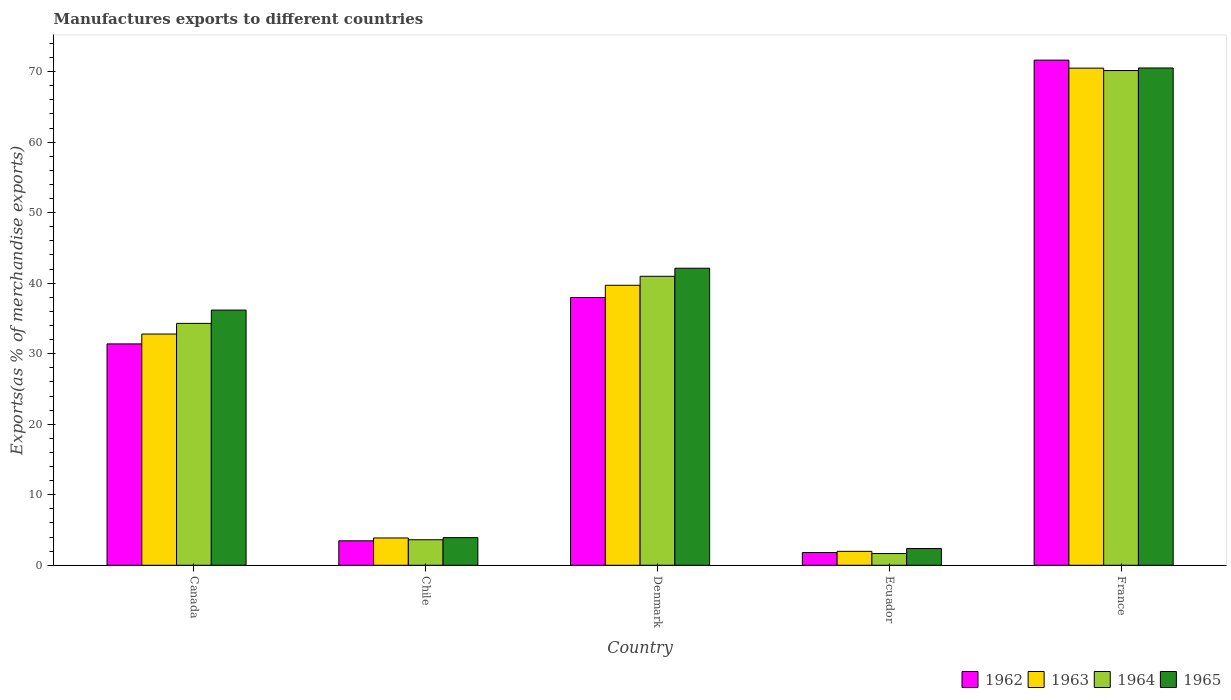How many different coloured bars are there?
Make the answer very short. 4. Are the number of bars per tick equal to the number of legend labels?
Make the answer very short. Yes. Are the number of bars on each tick of the X-axis equal?
Ensure brevity in your answer.  Yes. What is the label of the 4th group of bars from the left?
Ensure brevity in your answer.  Ecuador. What is the percentage of exports to different countries in 1965 in Ecuador?
Offer a very short reply. 2.37. Across all countries, what is the maximum percentage of exports to different countries in 1962?
Make the answer very short. 71.64. Across all countries, what is the minimum percentage of exports to different countries in 1962?
Keep it short and to the point. 1.8. In which country was the percentage of exports to different countries in 1965 maximum?
Give a very brief answer. France. In which country was the percentage of exports to different countries in 1962 minimum?
Your answer should be very brief. Ecuador. What is the total percentage of exports to different countries in 1964 in the graph?
Offer a terse response. 150.72. What is the difference between the percentage of exports to different countries in 1963 in Denmark and that in Ecuador?
Your response must be concise. 37.73. What is the difference between the percentage of exports to different countries in 1965 in Canada and the percentage of exports to different countries in 1964 in Denmark?
Your answer should be very brief. -4.79. What is the average percentage of exports to different countries in 1965 per country?
Give a very brief answer. 31.03. What is the difference between the percentage of exports to different countries of/in 1964 and percentage of exports to different countries of/in 1965 in France?
Your answer should be very brief. -0.36. In how many countries, is the percentage of exports to different countries in 1964 greater than 68 %?
Offer a terse response. 1. What is the ratio of the percentage of exports to different countries in 1965 in Denmark to that in Ecuador?
Offer a very short reply. 17.75. What is the difference between the highest and the second highest percentage of exports to different countries in 1963?
Give a very brief answer. -37.71. What is the difference between the highest and the lowest percentage of exports to different countries in 1963?
Provide a succinct answer. 68.53. Is it the case that in every country, the sum of the percentage of exports to different countries in 1965 and percentage of exports to different countries in 1962 is greater than the percentage of exports to different countries in 1963?
Provide a succinct answer. Yes. What is the difference between two consecutive major ticks on the Y-axis?
Keep it short and to the point. 10. Are the values on the major ticks of Y-axis written in scientific E-notation?
Your answer should be compact. No. Does the graph contain any zero values?
Make the answer very short. No. Does the graph contain grids?
Offer a very short reply. No. How many legend labels are there?
Offer a very short reply. 4. How are the legend labels stacked?
Your answer should be very brief. Horizontal. What is the title of the graph?
Your answer should be very brief. Manufactures exports to different countries. What is the label or title of the X-axis?
Offer a very short reply. Country. What is the label or title of the Y-axis?
Offer a very short reply. Exports(as % of merchandise exports). What is the Exports(as % of merchandise exports) of 1962 in Canada?
Give a very brief answer. 31.39. What is the Exports(as % of merchandise exports) in 1963 in Canada?
Your answer should be very brief. 32.79. What is the Exports(as % of merchandise exports) of 1964 in Canada?
Offer a very short reply. 34.3. What is the Exports(as % of merchandise exports) of 1965 in Canada?
Ensure brevity in your answer.  36.19. What is the Exports(as % of merchandise exports) in 1962 in Chile?
Your answer should be compact. 3.47. What is the Exports(as % of merchandise exports) of 1963 in Chile?
Offer a terse response. 3.87. What is the Exports(as % of merchandise exports) of 1964 in Chile?
Your answer should be compact. 3.62. What is the Exports(as % of merchandise exports) in 1965 in Chile?
Your answer should be compact. 3.92. What is the Exports(as % of merchandise exports) in 1962 in Denmark?
Your answer should be compact. 37.97. What is the Exports(as % of merchandise exports) in 1963 in Denmark?
Offer a very short reply. 39.71. What is the Exports(as % of merchandise exports) in 1964 in Denmark?
Your response must be concise. 40.98. What is the Exports(as % of merchandise exports) of 1965 in Denmark?
Offer a terse response. 42.12. What is the Exports(as % of merchandise exports) of 1962 in Ecuador?
Your response must be concise. 1.8. What is the Exports(as % of merchandise exports) in 1963 in Ecuador?
Provide a short and direct response. 1.97. What is the Exports(as % of merchandise exports) of 1964 in Ecuador?
Your response must be concise. 1.66. What is the Exports(as % of merchandise exports) in 1965 in Ecuador?
Provide a short and direct response. 2.37. What is the Exports(as % of merchandise exports) of 1962 in France?
Your answer should be compact. 71.64. What is the Exports(as % of merchandise exports) of 1963 in France?
Provide a short and direct response. 70.5. What is the Exports(as % of merchandise exports) in 1964 in France?
Give a very brief answer. 70.16. What is the Exports(as % of merchandise exports) of 1965 in France?
Your response must be concise. 70.52. Across all countries, what is the maximum Exports(as % of merchandise exports) in 1962?
Keep it short and to the point. 71.64. Across all countries, what is the maximum Exports(as % of merchandise exports) in 1963?
Offer a very short reply. 70.5. Across all countries, what is the maximum Exports(as % of merchandise exports) of 1964?
Offer a very short reply. 70.16. Across all countries, what is the maximum Exports(as % of merchandise exports) in 1965?
Offer a very short reply. 70.52. Across all countries, what is the minimum Exports(as % of merchandise exports) in 1962?
Provide a succinct answer. 1.8. Across all countries, what is the minimum Exports(as % of merchandise exports) of 1963?
Offer a terse response. 1.97. Across all countries, what is the minimum Exports(as % of merchandise exports) in 1964?
Your answer should be compact. 1.66. Across all countries, what is the minimum Exports(as % of merchandise exports) in 1965?
Offer a terse response. 2.37. What is the total Exports(as % of merchandise exports) of 1962 in the graph?
Provide a short and direct response. 146.27. What is the total Exports(as % of merchandise exports) in 1963 in the graph?
Provide a succinct answer. 148.84. What is the total Exports(as % of merchandise exports) of 1964 in the graph?
Offer a terse response. 150.72. What is the total Exports(as % of merchandise exports) in 1965 in the graph?
Make the answer very short. 155.13. What is the difference between the Exports(as % of merchandise exports) in 1962 in Canada and that in Chile?
Make the answer very short. 27.92. What is the difference between the Exports(as % of merchandise exports) of 1963 in Canada and that in Chile?
Provide a succinct answer. 28.92. What is the difference between the Exports(as % of merchandise exports) of 1964 in Canada and that in Chile?
Make the answer very short. 30.69. What is the difference between the Exports(as % of merchandise exports) of 1965 in Canada and that in Chile?
Offer a very short reply. 32.27. What is the difference between the Exports(as % of merchandise exports) in 1962 in Canada and that in Denmark?
Provide a succinct answer. -6.58. What is the difference between the Exports(as % of merchandise exports) in 1963 in Canada and that in Denmark?
Your answer should be compact. -6.92. What is the difference between the Exports(as % of merchandise exports) of 1964 in Canada and that in Denmark?
Your answer should be very brief. -6.68. What is the difference between the Exports(as % of merchandise exports) of 1965 in Canada and that in Denmark?
Give a very brief answer. -5.94. What is the difference between the Exports(as % of merchandise exports) of 1962 in Canada and that in Ecuador?
Offer a very short reply. 29.59. What is the difference between the Exports(as % of merchandise exports) in 1963 in Canada and that in Ecuador?
Give a very brief answer. 30.82. What is the difference between the Exports(as % of merchandise exports) in 1964 in Canada and that in Ecuador?
Your response must be concise. 32.64. What is the difference between the Exports(as % of merchandise exports) in 1965 in Canada and that in Ecuador?
Provide a short and direct response. 33.81. What is the difference between the Exports(as % of merchandise exports) of 1962 in Canada and that in France?
Provide a short and direct response. -40.24. What is the difference between the Exports(as % of merchandise exports) in 1963 in Canada and that in France?
Your answer should be very brief. -37.71. What is the difference between the Exports(as % of merchandise exports) in 1964 in Canada and that in France?
Give a very brief answer. -35.86. What is the difference between the Exports(as % of merchandise exports) of 1965 in Canada and that in France?
Give a very brief answer. -34.33. What is the difference between the Exports(as % of merchandise exports) of 1962 in Chile and that in Denmark?
Provide a short and direct response. -34.5. What is the difference between the Exports(as % of merchandise exports) of 1963 in Chile and that in Denmark?
Your answer should be compact. -35.84. What is the difference between the Exports(as % of merchandise exports) of 1964 in Chile and that in Denmark?
Provide a short and direct response. -37.36. What is the difference between the Exports(as % of merchandise exports) of 1965 in Chile and that in Denmark?
Your answer should be very brief. -38.21. What is the difference between the Exports(as % of merchandise exports) of 1962 in Chile and that in Ecuador?
Make the answer very short. 1.67. What is the difference between the Exports(as % of merchandise exports) in 1963 in Chile and that in Ecuador?
Ensure brevity in your answer.  1.9. What is the difference between the Exports(as % of merchandise exports) of 1964 in Chile and that in Ecuador?
Your answer should be very brief. 1.95. What is the difference between the Exports(as % of merchandise exports) of 1965 in Chile and that in Ecuador?
Ensure brevity in your answer.  1.54. What is the difference between the Exports(as % of merchandise exports) in 1962 in Chile and that in France?
Provide a succinct answer. -68.17. What is the difference between the Exports(as % of merchandise exports) of 1963 in Chile and that in France?
Make the answer very short. -66.63. What is the difference between the Exports(as % of merchandise exports) of 1964 in Chile and that in France?
Keep it short and to the point. -66.54. What is the difference between the Exports(as % of merchandise exports) in 1965 in Chile and that in France?
Your answer should be compact. -66.6. What is the difference between the Exports(as % of merchandise exports) in 1962 in Denmark and that in Ecuador?
Keep it short and to the point. 36.17. What is the difference between the Exports(as % of merchandise exports) of 1963 in Denmark and that in Ecuador?
Ensure brevity in your answer.  37.73. What is the difference between the Exports(as % of merchandise exports) of 1964 in Denmark and that in Ecuador?
Your answer should be very brief. 39.32. What is the difference between the Exports(as % of merchandise exports) of 1965 in Denmark and that in Ecuador?
Keep it short and to the point. 39.75. What is the difference between the Exports(as % of merchandise exports) of 1962 in Denmark and that in France?
Your answer should be very brief. -33.66. What is the difference between the Exports(as % of merchandise exports) in 1963 in Denmark and that in France?
Your answer should be compact. -30.79. What is the difference between the Exports(as % of merchandise exports) in 1964 in Denmark and that in France?
Give a very brief answer. -29.18. What is the difference between the Exports(as % of merchandise exports) in 1965 in Denmark and that in France?
Give a very brief answer. -28.4. What is the difference between the Exports(as % of merchandise exports) in 1962 in Ecuador and that in France?
Give a very brief answer. -69.83. What is the difference between the Exports(as % of merchandise exports) in 1963 in Ecuador and that in France?
Give a very brief answer. -68.53. What is the difference between the Exports(as % of merchandise exports) in 1964 in Ecuador and that in France?
Your response must be concise. -68.5. What is the difference between the Exports(as % of merchandise exports) in 1965 in Ecuador and that in France?
Provide a short and direct response. -68.15. What is the difference between the Exports(as % of merchandise exports) of 1962 in Canada and the Exports(as % of merchandise exports) of 1963 in Chile?
Give a very brief answer. 27.52. What is the difference between the Exports(as % of merchandise exports) of 1962 in Canada and the Exports(as % of merchandise exports) of 1964 in Chile?
Offer a terse response. 27.77. What is the difference between the Exports(as % of merchandise exports) of 1962 in Canada and the Exports(as % of merchandise exports) of 1965 in Chile?
Your answer should be compact. 27.47. What is the difference between the Exports(as % of merchandise exports) in 1963 in Canada and the Exports(as % of merchandise exports) in 1964 in Chile?
Provide a short and direct response. 29.17. What is the difference between the Exports(as % of merchandise exports) in 1963 in Canada and the Exports(as % of merchandise exports) in 1965 in Chile?
Your answer should be very brief. 28.87. What is the difference between the Exports(as % of merchandise exports) in 1964 in Canada and the Exports(as % of merchandise exports) in 1965 in Chile?
Your answer should be very brief. 30.39. What is the difference between the Exports(as % of merchandise exports) of 1962 in Canada and the Exports(as % of merchandise exports) of 1963 in Denmark?
Ensure brevity in your answer.  -8.31. What is the difference between the Exports(as % of merchandise exports) of 1962 in Canada and the Exports(as % of merchandise exports) of 1964 in Denmark?
Give a very brief answer. -9.59. What is the difference between the Exports(as % of merchandise exports) in 1962 in Canada and the Exports(as % of merchandise exports) in 1965 in Denmark?
Provide a succinct answer. -10.73. What is the difference between the Exports(as % of merchandise exports) of 1963 in Canada and the Exports(as % of merchandise exports) of 1964 in Denmark?
Keep it short and to the point. -8.19. What is the difference between the Exports(as % of merchandise exports) in 1963 in Canada and the Exports(as % of merchandise exports) in 1965 in Denmark?
Your answer should be compact. -9.33. What is the difference between the Exports(as % of merchandise exports) in 1964 in Canada and the Exports(as % of merchandise exports) in 1965 in Denmark?
Provide a succinct answer. -7.82. What is the difference between the Exports(as % of merchandise exports) in 1962 in Canada and the Exports(as % of merchandise exports) in 1963 in Ecuador?
Make the answer very short. 29.42. What is the difference between the Exports(as % of merchandise exports) in 1962 in Canada and the Exports(as % of merchandise exports) in 1964 in Ecuador?
Ensure brevity in your answer.  29.73. What is the difference between the Exports(as % of merchandise exports) in 1962 in Canada and the Exports(as % of merchandise exports) in 1965 in Ecuador?
Provide a succinct answer. 29.02. What is the difference between the Exports(as % of merchandise exports) of 1963 in Canada and the Exports(as % of merchandise exports) of 1964 in Ecuador?
Give a very brief answer. 31.13. What is the difference between the Exports(as % of merchandise exports) of 1963 in Canada and the Exports(as % of merchandise exports) of 1965 in Ecuador?
Your answer should be very brief. 30.42. What is the difference between the Exports(as % of merchandise exports) in 1964 in Canada and the Exports(as % of merchandise exports) in 1965 in Ecuador?
Your response must be concise. 31.93. What is the difference between the Exports(as % of merchandise exports) of 1962 in Canada and the Exports(as % of merchandise exports) of 1963 in France?
Offer a very short reply. -39.11. What is the difference between the Exports(as % of merchandise exports) in 1962 in Canada and the Exports(as % of merchandise exports) in 1964 in France?
Your response must be concise. -38.77. What is the difference between the Exports(as % of merchandise exports) in 1962 in Canada and the Exports(as % of merchandise exports) in 1965 in France?
Provide a succinct answer. -39.13. What is the difference between the Exports(as % of merchandise exports) in 1963 in Canada and the Exports(as % of merchandise exports) in 1964 in France?
Ensure brevity in your answer.  -37.37. What is the difference between the Exports(as % of merchandise exports) in 1963 in Canada and the Exports(as % of merchandise exports) in 1965 in France?
Offer a terse response. -37.73. What is the difference between the Exports(as % of merchandise exports) in 1964 in Canada and the Exports(as % of merchandise exports) in 1965 in France?
Give a very brief answer. -36.22. What is the difference between the Exports(as % of merchandise exports) in 1962 in Chile and the Exports(as % of merchandise exports) in 1963 in Denmark?
Your answer should be compact. -36.24. What is the difference between the Exports(as % of merchandise exports) of 1962 in Chile and the Exports(as % of merchandise exports) of 1964 in Denmark?
Make the answer very short. -37.51. What is the difference between the Exports(as % of merchandise exports) in 1962 in Chile and the Exports(as % of merchandise exports) in 1965 in Denmark?
Ensure brevity in your answer.  -38.66. What is the difference between the Exports(as % of merchandise exports) of 1963 in Chile and the Exports(as % of merchandise exports) of 1964 in Denmark?
Ensure brevity in your answer.  -37.11. What is the difference between the Exports(as % of merchandise exports) in 1963 in Chile and the Exports(as % of merchandise exports) in 1965 in Denmark?
Offer a terse response. -38.25. What is the difference between the Exports(as % of merchandise exports) in 1964 in Chile and the Exports(as % of merchandise exports) in 1965 in Denmark?
Provide a succinct answer. -38.51. What is the difference between the Exports(as % of merchandise exports) of 1962 in Chile and the Exports(as % of merchandise exports) of 1963 in Ecuador?
Keep it short and to the point. 1.49. What is the difference between the Exports(as % of merchandise exports) of 1962 in Chile and the Exports(as % of merchandise exports) of 1964 in Ecuador?
Your answer should be compact. 1.81. What is the difference between the Exports(as % of merchandise exports) in 1962 in Chile and the Exports(as % of merchandise exports) in 1965 in Ecuador?
Offer a very short reply. 1.1. What is the difference between the Exports(as % of merchandise exports) of 1963 in Chile and the Exports(as % of merchandise exports) of 1964 in Ecuador?
Provide a short and direct response. 2.21. What is the difference between the Exports(as % of merchandise exports) in 1963 in Chile and the Exports(as % of merchandise exports) in 1965 in Ecuador?
Keep it short and to the point. 1.5. What is the difference between the Exports(as % of merchandise exports) in 1964 in Chile and the Exports(as % of merchandise exports) in 1965 in Ecuador?
Provide a short and direct response. 1.24. What is the difference between the Exports(as % of merchandise exports) of 1962 in Chile and the Exports(as % of merchandise exports) of 1963 in France?
Offer a very short reply. -67.03. What is the difference between the Exports(as % of merchandise exports) of 1962 in Chile and the Exports(as % of merchandise exports) of 1964 in France?
Keep it short and to the point. -66.69. What is the difference between the Exports(as % of merchandise exports) in 1962 in Chile and the Exports(as % of merchandise exports) in 1965 in France?
Offer a terse response. -67.05. What is the difference between the Exports(as % of merchandise exports) in 1963 in Chile and the Exports(as % of merchandise exports) in 1964 in France?
Your answer should be very brief. -66.29. What is the difference between the Exports(as % of merchandise exports) in 1963 in Chile and the Exports(as % of merchandise exports) in 1965 in France?
Ensure brevity in your answer.  -66.65. What is the difference between the Exports(as % of merchandise exports) in 1964 in Chile and the Exports(as % of merchandise exports) in 1965 in France?
Make the answer very short. -66.9. What is the difference between the Exports(as % of merchandise exports) in 1962 in Denmark and the Exports(as % of merchandise exports) in 1963 in Ecuador?
Provide a succinct answer. 36. What is the difference between the Exports(as % of merchandise exports) in 1962 in Denmark and the Exports(as % of merchandise exports) in 1964 in Ecuador?
Provide a short and direct response. 36.31. What is the difference between the Exports(as % of merchandise exports) in 1962 in Denmark and the Exports(as % of merchandise exports) in 1965 in Ecuador?
Your response must be concise. 35.6. What is the difference between the Exports(as % of merchandise exports) in 1963 in Denmark and the Exports(as % of merchandise exports) in 1964 in Ecuador?
Provide a succinct answer. 38.04. What is the difference between the Exports(as % of merchandise exports) in 1963 in Denmark and the Exports(as % of merchandise exports) in 1965 in Ecuador?
Provide a succinct answer. 37.33. What is the difference between the Exports(as % of merchandise exports) of 1964 in Denmark and the Exports(as % of merchandise exports) of 1965 in Ecuador?
Your answer should be compact. 38.61. What is the difference between the Exports(as % of merchandise exports) of 1962 in Denmark and the Exports(as % of merchandise exports) of 1963 in France?
Offer a very short reply. -32.53. What is the difference between the Exports(as % of merchandise exports) of 1962 in Denmark and the Exports(as % of merchandise exports) of 1964 in France?
Your response must be concise. -32.19. What is the difference between the Exports(as % of merchandise exports) of 1962 in Denmark and the Exports(as % of merchandise exports) of 1965 in France?
Your answer should be very brief. -32.55. What is the difference between the Exports(as % of merchandise exports) in 1963 in Denmark and the Exports(as % of merchandise exports) in 1964 in France?
Offer a very short reply. -30.45. What is the difference between the Exports(as % of merchandise exports) of 1963 in Denmark and the Exports(as % of merchandise exports) of 1965 in France?
Provide a succinct answer. -30.82. What is the difference between the Exports(as % of merchandise exports) in 1964 in Denmark and the Exports(as % of merchandise exports) in 1965 in France?
Give a very brief answer. -29.54. What is the difference between the Exports(as % of merchandise exports) in 1962 in Ecuador and the Exports(as % of merchandise exports) in 1963 in France?
Provide a short and direct response. -68.7. What is the difference between the Exports(as % of merchandise exports) of 1962 in Ecuador and the Exports(as % of merchandise exports) of 1964 in France?
Offer a very short reply. -68.35. What is the difference between the Exports(as % of merchandise exports) of 1962 in Ecuador and the Exports(as % of merchandise exports) of 1965 in France?
Keep it short and to the point. -68.72. What is the difference between the Exports(as % of merchandise exports) in 1963 in Ecuador and the Exports(as % of merchandise exports) in 1964 in France?
Give a very brief answer. -68.18. What is the difference between the Exports(as % of merchandise exports) of 1963 in Ecuador and the Exports(as % of merchandise exports) of 1965 in France?
Offer a terse response. -68.55. What is the difference between the Exports(as % of merchandise exports) of 1964 in Ecuador and the Exports(as % of merchandise exports) of 1965 in France?
Make the answer very short. -68.86. What is the average Exports(as % of merchandise exports) in 1962 per country?
Your response must be concise. 29.25. What is the average Exports(as % of merchandise exports) in 1963 per country?
Offer a very short reply. 29.77. What is the average Exports(as % of merchandise exports) of 1964 per country?
Your response must be concise. 30.14. What is the average Exports(as % of merchandise exports) in 1965 per country?
Ensure brevity in your answer.  31.03. What is the difference between the Exports(as % of merchandise exports) of 1962 and Exports(as % of merchandise exports) of 1963 in Canada?
Keep it short and to the point. -1.4. What is the difference between the Exports(as % of merchandise exports) in 1962 and Exports(as % of merchandise exports) in 1964 in Canada?
Make the answer very short. -2.91. What is the difference between the Exports(as % of merchandise exports) in 1962 and Exports(as % of merchandise exports) in 1965 in Canada?
Your answer should be compact. -4.8. What is the difference between the Exports(as % of merchandise exports) of 1963 and Exports(as % of merchandise exports) of 1964 in Canada?
Offer a terse response. -1.51. What is the difference between the Exports(as % of merchandise exports) of 1963 and Exports(as % of merchandise exports) of 1965 in Canada?
Keep it short and to the point. -3.4. What is the difference between the Exports(as % of merchandise exports) in 1964 and Exports(as % of merchandise exports) in 1965 in Canada?
Offer a very short reply. -1.89. What is the difference between the Exports(as % of merchandise exports) in 1962 and Exports(as % of merchandise exports) in 1963 in Chile?
Make the answer very short. -0.4. What is the difference between the Exports(as % of merchandise exports) of 1962 and Exports(as % of merchandise exports) of 1964 in Chile?
Keep it short and to the point. -0.15. What is the difference between the Exports(as % of merchandise exports) in 1962 and Exports(as % of merchandise exports) in 1965 in Chile?
Offer a very short reply. -0.45. What is the difference between the Exports(as % of merchandise exports) of 1963 and Exports(as % of merchandise exports) of 1964 in Chile?
Your answer should be very brief. 0.25. What is the difference between the Exports(as % of merchandise exports) of 1963 and Exports(as % of merchandise exports) of 1965 in Chile?
Provide a succinct answer. -0.05. What is the difference between the Exports(as % of merchandise exports) in 1964 and Exports(as % of merchandise exports) in 1965 in Chile?
Ensure brevity in your answer.  -0.3. What is the difference between the Exports(as % of merchandise exports) in 1962 and Exports(as % of merchandise exports) in 1963 in Denmark?
Ensure brevity in your answer.  -1.74. What is the difference between the Exports(as % of merchandise exports) in 1962 and Exports(as % of merchandise exports) in 1964 in Denmark?
Provide a succinct answer. -3.01. What is the difference between the Exports(as % of merchandise exports) of 1962 and Exports(as % of merchandise exports) of 1965 in Denmark?
Give a very brief answer. -4.15. What is the difference between the Exports(as % of merchandise exports) in 1963 and Exports(as % of merchandise exports) in 1964 in Denmark?
Offer a very short reply. -1.27. What is the difference between the Exports(as % of merchandise exports) in 1963 and Exports(as % of merchandise exports) in 1965 in Denmark?
Provide a succinct answer. -2.42. What is the difference between the Exports(as % of merchandise exports) of 1964 and Exports(as % of merchandise exports) of 1965 in Denmark?
Your answer should be compact. -1.14. What is the difference between the Exports(as % of merchandise exports) of 1962 and Exports(as % of merchandise exports) of 1963 in Ecuador?
Offer a very short reply. -0.17. What is the difference between the Exports(as % of merchandise exports) of 1962 and Exports(as % of merchandise exports) of 1964 in Ecuador?
Provide a short and direct response. 0.14. What is the difference between the Exports(as % of merchandise exports) in 1962 and Exports(as % of merchandise exports) in 1965 in Ecuador?
Provide a succinct answer. -0.57. What is the difference between the Exports(as % of merchandise exports) in 1963 and Exports(as % of merchandise exports) in 1964 in Ecuador?
Make the answer very short. 0.31. What is the difference between the Exports(as % of merchandise exports) of 1963 and Exports(as % of merchandise exports) of 1965 in Ecuador?
Provide a succinct answer. -0.4. What is the difference between the Exports(as % of merchandise exports) of 1964 and Exports(as % of merchandise exports) of 1965 in Ecuador?
Your response must be concise. -0.71. What is the difference between the Exports(as % of merchandise exports) in 1962 and Exports(as % of merchandise exports) in 1963 in France?
Provide a succinct answer. 1.13. What is the difference between the Exports(as % of merchandise exports) of 1962 and Exports(as % of merchandise exports) of 1964 in France?
Keep it short and to the point. 1.48. What is the difference between the Exports(as % of merchandise exports) of 1962 and Exports(as % of merchandise exports) of 1965 in France?
Provide a succinct answer. 1.11. What is the difference between the Exports(as % of merchandise exports) of 1963 and Exports(as % of merchandise exports) of 1964 in France?
Your response must be concise. 0.34. What is the difference between the Exports(as % of merchandise exports) of 1963 and Exports(as % of merchandise exports) of 1965 in France?
Ensure brevity in your answer.  -0.02. What is the difference between the Exports(as % of merchandise exports) in 1964 and Exports(as % of merchandise exports) in 1965 in France?
Offer a very short reply. -0.36. What is the ratio of the Exports(as % of merchandise exports) in 1962 in Canada to that in Chile?
Offer a very short reply. 9.05. What is the ratio of the Exports(as % of merchandise exports) in 1963 in Canada to that in Chile?
Your answer should be compact. 8.47. What is the ratio of the Exports(as % of merchandise exports) in 1964 in Canada to that in Chile?
Provide a succinct answer. 9.48. What is the ratio of the Exports(as % of merchandise exports) in 1965 in Canada to that in Chile?
Make the answer very short. 9.24. What is the ratio of the Exports(as % of merchandise exports) of 1962 in Canada to that in Denmark?
Offer a very short reply. 0.83. What is the ratio of the Exports(as % of merchandise exports) in 1963 in Canada to that in Denmark?
Your answer should be compact. 0.83. What is the ratio of the Exports(as % of merchandise exports) of 1964 in Canada to that in Denmark?
Your answer should be very brief. 0.84. What is the ratio of the Exports(as % of merchandise exports) in 1965 in Canada to that in Denmark?
Your answer should be compact. 0.86. What is the ratio of the Exports(as % of merchandise exports) in 1962 in Canada to that in Ecuador?
Your response must be concise. 17.41. What is the ratio of the Exports(as % of merchandise exports) of 1963 in Canada to that in Ecuador?
Ensure brevity in your answer.  16.61. What is the ratio of the Exports(as % of merchandise exports) in 1964 in Canada to that in Ecuador?
Ensure brevity in your answer.  20.63. What is the ratio of the Exports(as % of merchandise exports) in 1965 in Canada to that in Ecuador?
Your answer should be compact. 15.25. What is the ratio of the Exports(as % of merchandise exports) in 1962 in Canada to that in France?
Your response must be concise. 0.44. What is the ratio of the Exports(as % of merchandise exports) of 1963 in Canada to that in France?
Ensure brevity in your answer.  0.47. What is the ratio of the Exports(as % of merchandise exports) in 1964 in Canada to that in France?
Provide a short and direct response. 0.49. What is the ratio of the Exports(as % of merchandise exports) in 1965 in Canada to that in France?
Offer a very short reply. 0.51. What is the ratio of the Exports(as % of merchandise exports) of 1962 in Chile to that in Denmark?
Your answer should be very brief. 0.09. What is the ratio of the Exports(as % of merchandise exports) in 1963 in Chile to that in Denmark?
Provide a succinct answer. 0.1. What is the ratio of the Exports(as % of merchandise exports) of 1964 in Chile to that in Denmark?
Offer a terse response. 0.09. What is the ratio of the Exports(as % of merchandise exports) of 1965 in Chile to that in Denmark?
Keep it short and to the point. 0.09. What is the ratio of the Exports(as % of merchandise exports) of 1962 in Chile to that in Ecuador?
Ensure brevity in your answer.  1.92. What is the ratio of the Exports(as % of merchandise exports) in 1963 in Chile to that in Ecuador?
Ensure brevity in your answer.  1.96. What is the ratio of the Exports(as % of merchandise exports) of 1964 in Chile to that in Ecuador?
Keep it short and to the point. 2.18. What is the ratio of the Exports(as % of merchandise exports) in 1965 in Chile to that in Ecuador?
Provide a succinct answer. 1.65. What is the ratio of the Exports(as % of merchandise exports) in 1962 in Chile to that in France?
Your answer should be very brief. 0.05. What is the ratio of the Exports(as % of merchandise exports) in 1963 in Chile to that in France?
Your answer should be compact. 0.05. What is the ratio of the Exports(as % of merchandise exports) of 1964 in Chile to that in France?
Offer a terse response. 0.05. What is the ratio of the Exports(as % of merchandise exports) in 1965 in Chile to that in France?
Your response must be concise. 0.06. What is the ratio of the Exports(as % of merchandise exports) of 1962 in Denmark to that in Ecuador?
Offer a terse response. 21.05. What is the ratio of the Exports(as % of merchandise exports) in 1963 in Denmark to that in Ecuador?
Your answer should be very brief. 20.11. What is the ratio of the Exports(as % of merchandise exports) in 1964 in Denmark to that in Ecuador?
Offer a very short reply. 24.64. What is the ratio of the Exports(as % of merchandise exports) of 1965 in Denmark to that in Ecuador?
Make the answer very short. 17.75. What is the ratio of the Exports(as % of merchandise exports) in 1962 in Denmark to that in France?
Offer a terse response. 0.53. What is the ratio of the Exports(as % of merchandise exports) of 1963 in Denmark to that in France?
Give a very brief answer. 0.56. What is the ratio of the Exports(as % of merchandise exports) of 1964 in Denmark to that in France?
Provide a succinct answer. 0.58. What is the ratio of the Exports(as % of merchandise exports) in 1965 in Denmark to that in France?
Provide a succinct answer. 0.6. What is the ratio of the Exports(as % of merchandise exports) in 1962 in Ecuador to that in France?
Ensure brevity in your answer.  0.03. What is the ratio of the Exports(as % of merchandise exports) of 1963 in Ecuador to that in France?
Your response must be concise. 0.03. What is the ratio of the Exports(as % of merchandise exports) of 1964 in Ecuador to that in France?
Ensure brevity in your answer.  0.02. What is the ratio of the Exports(as % of merchandise exports) in 1965 in Ecuador to that in France?
Make the answer very short. 0.03. What is the difference between the highest and the second highest Exports(as % of merchandise exports) of 1962?
Your answer should be very brief. 33.66. What is the difference between the highest and the second highest Exports(as % of merchandise exports) in 1963?
Make the answer very short. 30.79. What is the difference between the highest and the second highest Exports(as % of merchandise exports) of 1964?
Ensure brevity in your answer.  29.18. What is the difference between the highest and the second highest Exports(as % of merchandise exports) in 1965?
Make the answer very short. 28.4. What is the difference between the highest and the lowest Exports(as % of merchandise exports) in 1962?
Your response must be concise. 69.83. What is the difference between the highest and the lowest Exports(as % of merchandise exports) in 1963?
Offer a terse response. 68.53. What is the difference between the highest and the lowest Exports(as % of merchandise exports) of 1964?
Keep it short and to the point. 68.5. What is the difference between the highest and the lowest Exports(as % of merchandise exports) in 1965?
Your response must be concise. 68.15. 